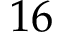Convert formula to latex. <formula><loc_0><loc_0><loc_500><loc_500>1 6</formula> 